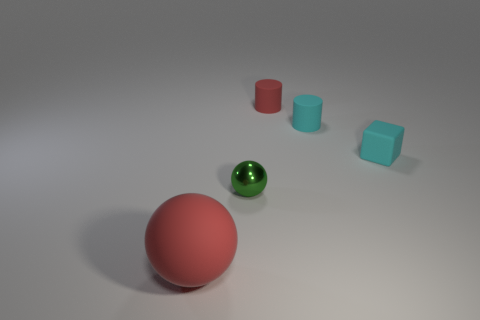Is there any other thing that has the same material as the small green object?
Provide a short and direct response. No. There is a matte cylinder that is the same color as the large ball; what size is it?
Provide a short and direct response. Small. What is the red thing that is behind the rubber thing in front of the small sphere that is on the right side of the rubber sphere made of?
Offer a terse response. Rubber. What number of tiny shiny balls are behind the red object that is to the right of the big ball?
Your response must be concise. 0. There is a cyan cylinder that is on the left side of the cyan cube; is it the same size as the big matte sphere?
Ensure brevity in your answer.  No. What number of small metallic things have the same shape as the tiny red rubber object?
Provide a short and direct response. 0. What is the shape of the large red rubber thing?
Ensure brevity in your answer.  Sphere. Are there an equal number of large objects to the left of the tiny red cylinder and large red rubber balls?
Ensure brevity in your answer.  Yes. Do the cylinder in front of the tiny red thing and the red ball have the same material?
Your answer should be compact. Yes. Are there fewer tiny metallic spheres that are on the left side of the tiny shiny object than tiny red metallic blocks?
Your response must be concise. No. 